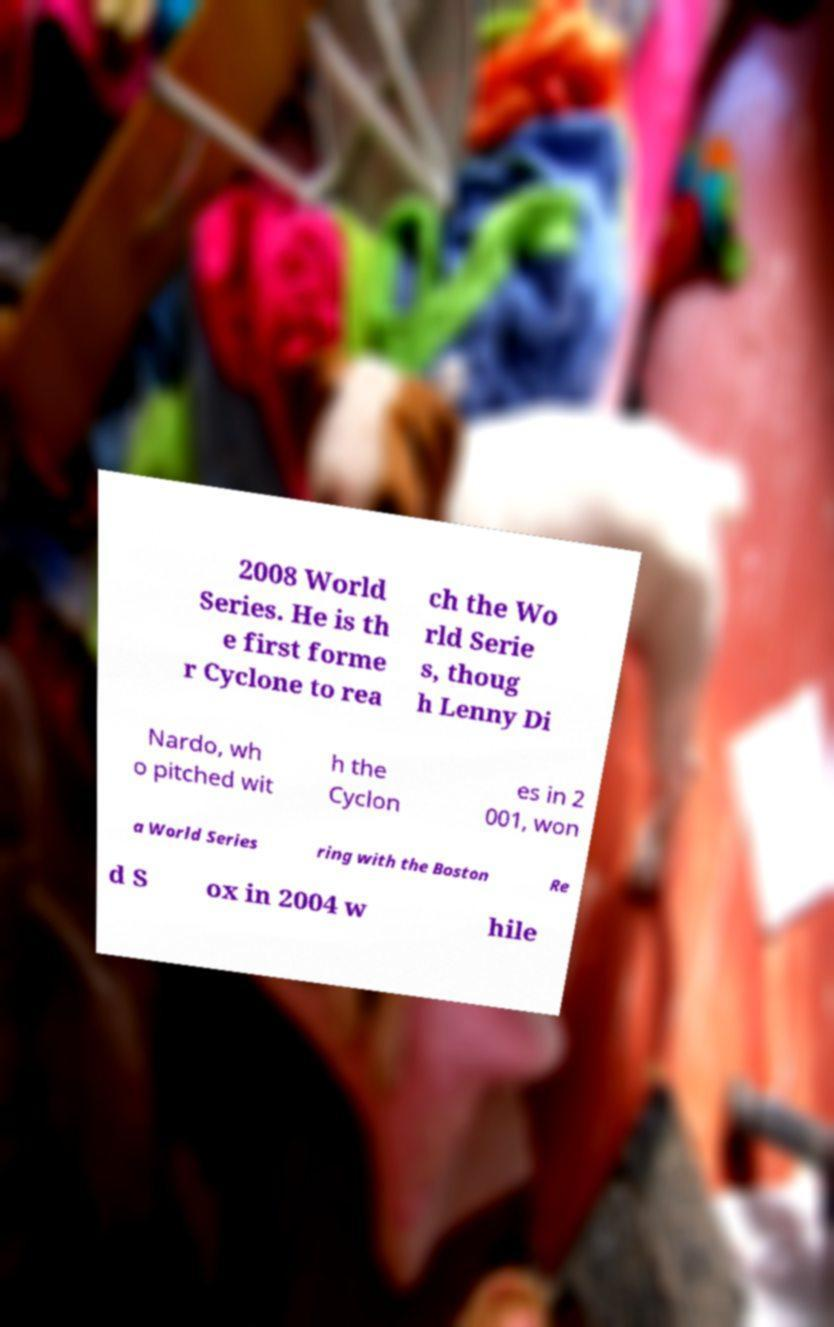Could you extract and type out the text from this image? 2008 World Series. He is th e first forme r Cyclone to rea ch the Wo rld Serie s, thoug h Lenny Di Nardo, wh o pitched wit h the Cyclon es in 2 001, won a World Series ring with the Boston Re d S ox in 2004 w hile 